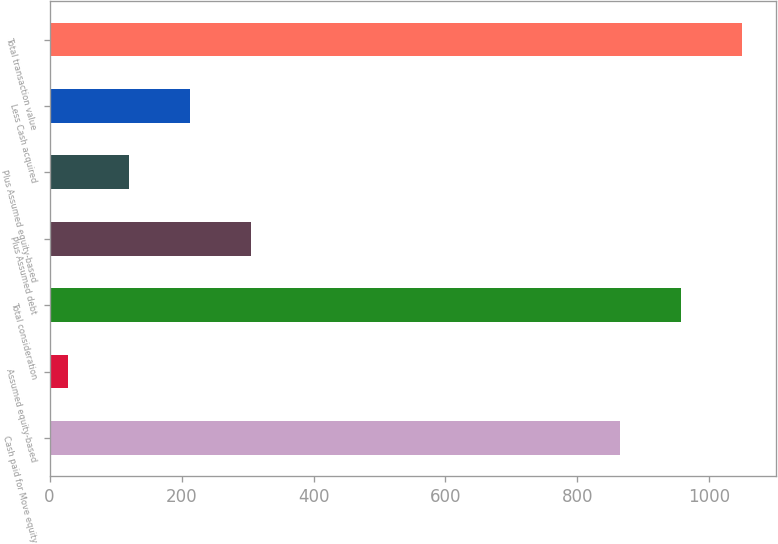<chart> <loc_0><loc_0><loc_500><loc_500><bar_chart><fcel>Cash paid for Move equity<fcel>Assumed equity-based<fcel>Total consideration<fcel>Plus Assumed debt<fcel>Plus Assumed equity-based<fcel>Less Cash acquired<fcel>Total transaction value<nl><fcel>864<fcel>28<fcel>956.4<fcel>305.2<fcel>120.4<fcel>212.8<fcel>1048.8<nl></chart> 